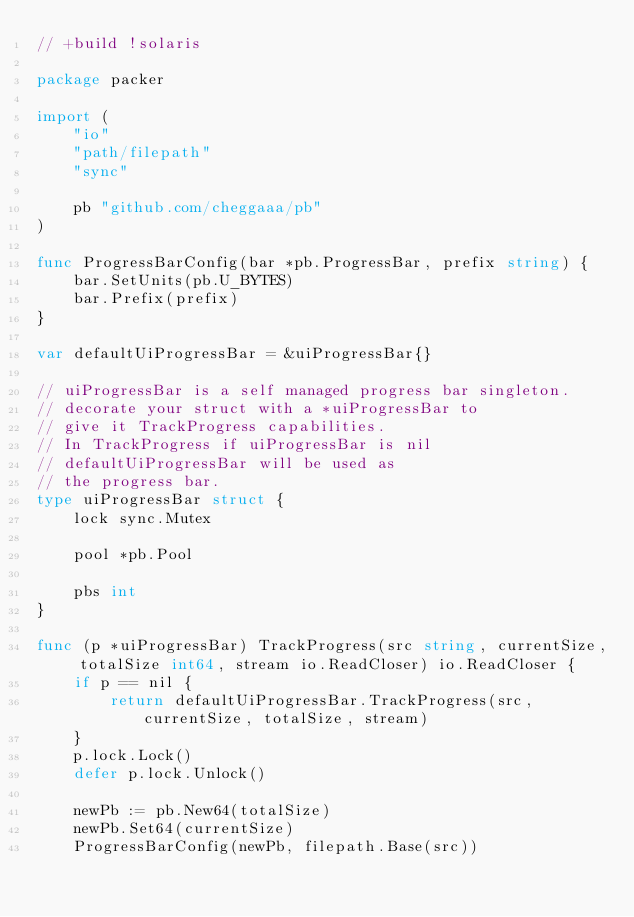Convert code to text. <code><loc_0><loc_0><loc_500><loc_500><_Go_>// +build !solaris

package packer

import (
	"io"
	"path/filepath"
	"sync"

	pb "github.com/cheggaaa/pb"
)

func ProgressBarConfig(bar *pb.ProgressBar, prefix string) {
	bar.SetUnits(pb.U_BYTES)
	bar.Prefix(prefix)
}

var defaultUiProgressBar = &uiProgressBar{}

// uiProgressBar is a self managed progress bar singleton.
// decorate your struct with a *uiProgressBar to
// give it TrackProgress capabilities.
// In TrackProgress if uiProgressBar is nil
// defaultUiProgressBar will be used as
// the progress bar.
type uiProgressBar struct {
	lock sync.Mutex

	pool *pb.Pool

	pbs int
}

func (p *uiProgressBar) TrackProgress(src string, currentSize, totalSize int64, stream io.ReadCloser) io.ReadCloser {
	if p == nil {
		return defaultUiProgressBar.TrackProgress(src, currentSize, totalSize, stream)
	}
	p.lock.Lock()
	defer p.lock.Unlock()

	newPb := pb.New64(totalSize)
	newPb.Set64(currentSize)
	ProgressBarConfig(newPb, filepath.Base(src))
</code> 